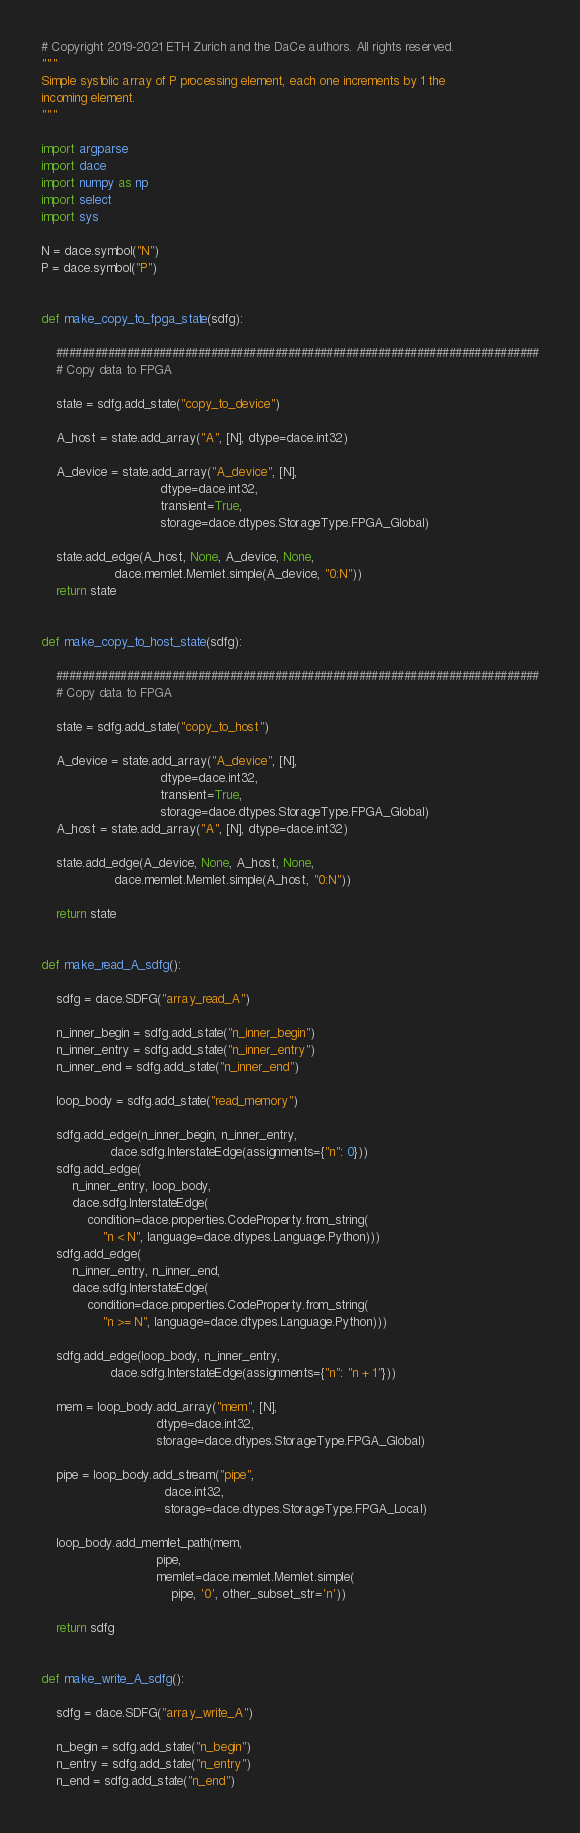Convert code to text. <code><loc_0><loc_0><loc_500><loc_500><_Python_># Copyright 2019-2021 ETH Zurich and the DaCe authors. All rights reserved.
"""
Simple systolic array of P processing element, each one increments by 1 the
incoming element.
"""

import argparse
import dace
import numpy as np
import select
import sys

N = dace.symbol("N")
P = dace.symbol("P")


def make_copy_to_fpga_state(sdfg):

    ###########################################################################
    # Copy data to FPGA

    state = sdfg.add_state("copy_to_device")

    A_host = state.add_array("A", [N], dtype=dace.int32)

    A_device = state.add_array("A_device", [N],
                               dtype=dace.int32,
                               transient=True,
                               storage=dace.dtypes.StorageType.FPGA_Global)

    state.add_edge(A_host, None, A_device, None,
                   dace.memlet.Memlet.simple(A_device, "0:N"))
    return state


def make_copy_to_host_state(sdfg):

    ###########################################################################
    # Copy data to FPGA

    state = sdfg.add_state("copy_to_host")

    A_device = state.add_array("A_device", [N],
                               dtype=dace.int32,
                               transient=True,
                               storage=dace.dtypes.StorageType.FPGA_Global)
    A_host = state.add_array("A", [N], dtype=dace.int32)

    state.add_edge(A_device, None, A_host, None,
                   dace.memlet.Memlet.simple(A_host, "0:N"))

    return state


def make_read_A_sdfg():

    sdfg = dace.SDFG("array_read_A")

    n_inner_begin = sdfg.add_state("n_inner_begin")
    n_inner_entry = sdfg.add_state("n_inner_entry")
    n_inner_end = sdfg.add_state("n_inner_end")

    loop_body = sdfg.add_state("read_memory")

    sdfg.add_edge(n_inner_begin, n_inner_entry,
                  dace.sdfg.InterstateEdge(assignments={"n": 0}))
    sdfg.add_edge(
        n_inner_entry, loop_body,
        dace.sdfg.InterstateEdge(
            condition=dace.properties.CodeProperty.from_string(
                "n < N", language=dace.dtypes.Language.Python)))
    sdfg.add_edge(
        n_inner_entry, n_inner_end,
        dace.sdfg.InterstateEdge(
            condition=dace.properties.CodeProperty.from_string(
                "n >= N", language=dace.dtypes.Language.Python)))

    sdfg.add_edge(loop_body, n_inner_entry,
                  dace.sdfg.InterstateEdge(assignments={"n": "n + 1"}))

    mem = loop_body.add_array("mem", [N],
                              dtype=dace.int32,
                              storage=dace.dtypes.StorageType.FPGA_Global)

    pipe = loop_body.add_stream("pipe",
                                dace.int32,
                                storage=dace.dtypes.StorageType.FPGA_Local)

    loop_body.add_memlet_path(mem,
                              pipe,
                              memlet=dace.memlet.Memlet.simple(
                                  pipe, '0', other_subset_str='n'))

    return sdfg


def make_write_A_sdfg():

    sdfg = dace.SDFG("array_write_A")

    n_begin = sdfg.add_state("n_begin")
    n_entry = sdfg.add_state("n_entry")
    n_end = sdfg.add_state("n_end")
</code> 